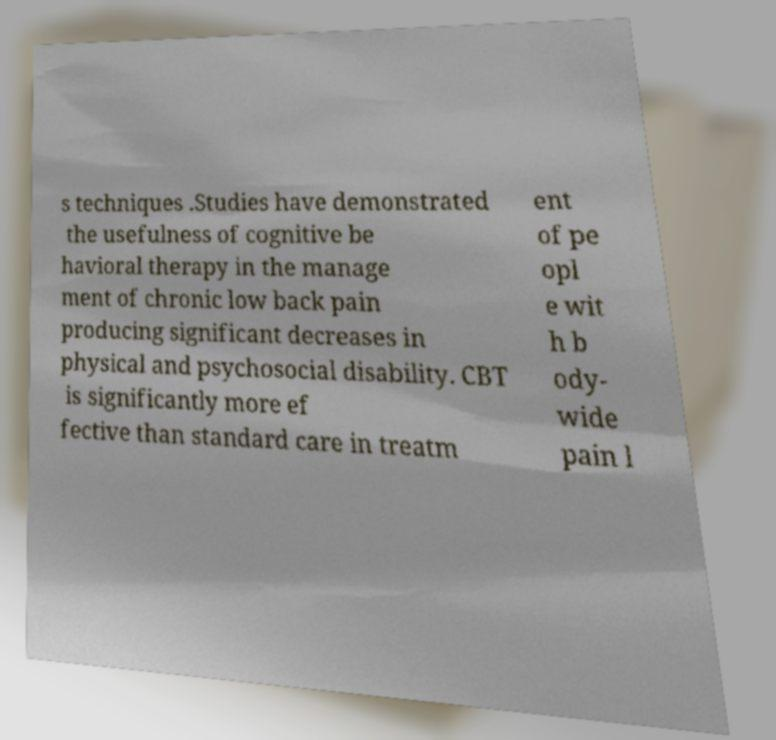Please identify and transcribe the text found in this image. s techniques .Studies have demonstrated the usefulness of cognitive be havioral therapy in the manage ment of chronic low back pain producing significant decreases in physical and psychosocial disability. CBT is significantly more ef fective than standard care in treatm ent of pe opl e wit h b ody- wide pain l 